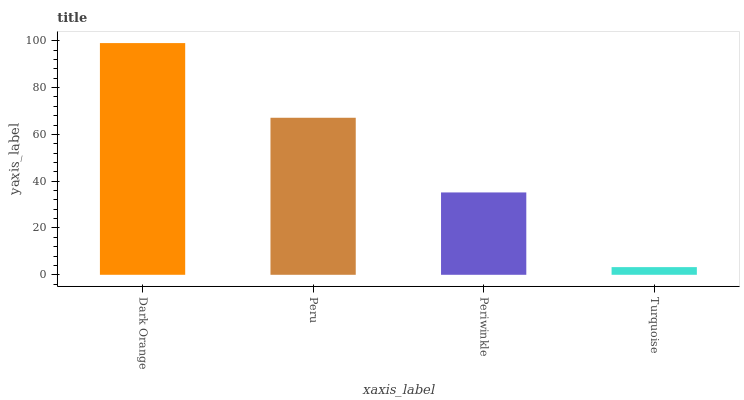Is Turquoise the minimum?
Answer yes or no. Yes. Is Dark Orange the maximum?
Answer yes or no. Yes. Is Peru the minimum?
Answer yes or no. No. Is Peru the maximum?
Answer yes or no. No. Is Dark Orange greater than Peru?
Answer yes or no. Yes. Is Peru less than Dark Orange?
Answer yes or no. Yes. Is Peru greater than Dark Orange?
Answer yes or no. No. Is Dark Orange less than Peru?
Answer yes or no. No. Is Peru the high median?
Answer yes or no. Yes. Is Periwinkle the low median?
Answer yes or no. Yes. Is Turquoise the high median?
Answer yes or no. No. Is Turquoise the low median?
Answer yes or no. No. 